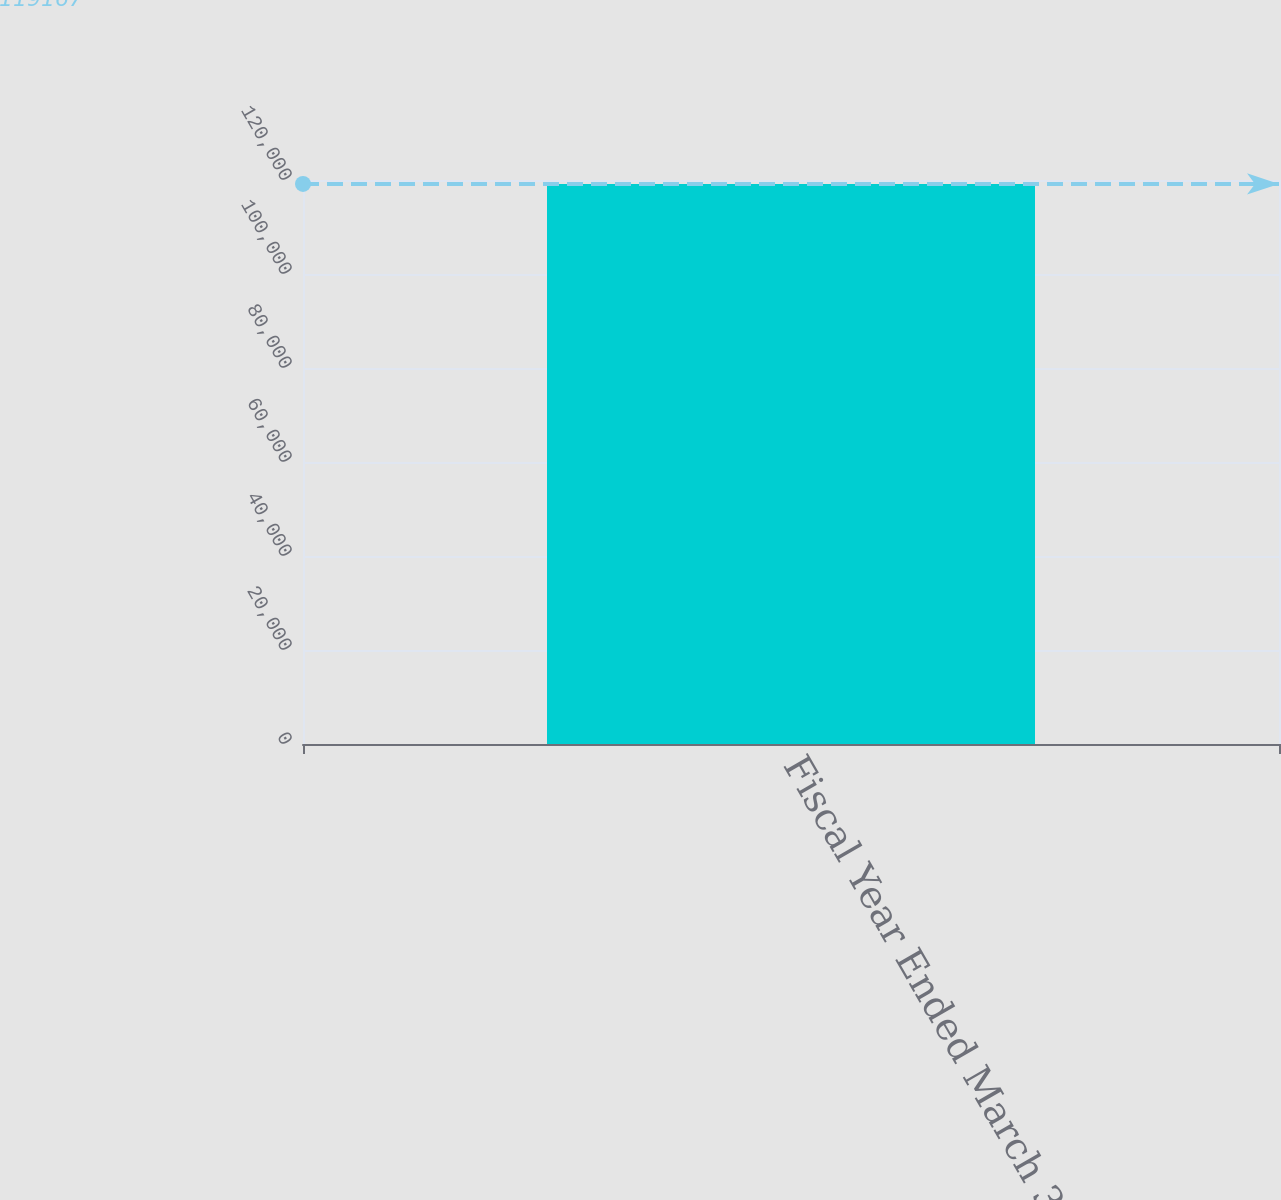Convert chart to OTSL. <chart><loc_0><loc_0><loc_500><loc_500><bar_chart><fcel>Fiscal Year Ended March 31<nl><fcel>119167<nl></chart> 